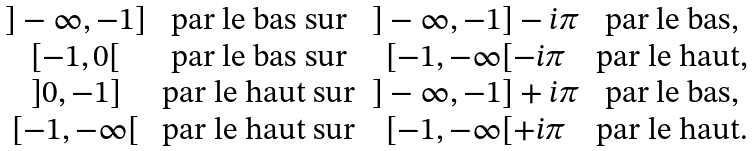<formula> <loc_0><loc_0><loc_500><loc_500>\begin{matrix} ] - \infty , - 1 ] & \text {par le bas sur} & ] - \infty , - 1 ] - i \pi & \text {par le bas,} \\ [ - 1 , 0 [ & \text {par le bas sur} & [ - 1 , - \infty [ - i \pi & \text {par le haut,} \\ ] 0 , - 1 ] & \text {par le haut sur} & ] - \infty , - 1 ] + i \pi & \text {par le bas,} \\ [ - 1 , - \infty [ & \text {par le haut sur} & [ - 1 , - \infty [ + i \pi & \text {par le haut.} \\ \end{matrix}</formula> 